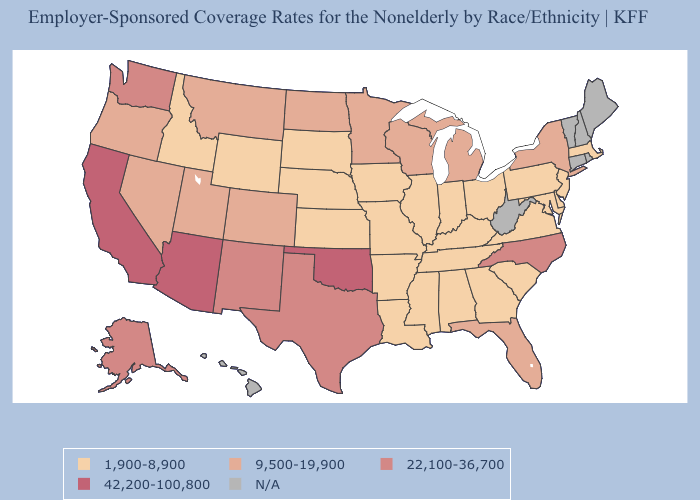Is the legend a continuous bar?
Answer briefly. No. Does North Carolina have the lowest value in the USA?
Keep it brief. No. What is the value of Washington?
Concise answer only. 22,100-36,700. Which states have the lowest value in the USA?
Short answer required. Alabama, Arkansas, Delaware, Georgia, Idaho, Illinois, Indiana, Iowa, Kansas, Kentucky, Louisiana, Maryland, Massachusetts, Mississippi, Missouri, Nebraska, New Jersey, Ohio, Pennsylvania, South Carolina, South Dakota, Tennessee, Virginia, Wyoming. What is the highest value in the USA?
Short answer required. 42,200-100,800. Does the map have missing data?
Be succinct. Yes. What is the value of Illinois?
Quick response, please. 1,900-8,900. What is the value of Kansas?
Answer briefly. 1,900-8,900. What is the value of Oklahoma?
Write a very short answer. 42,200-100,800. Name the states that have a value in the range 22,100-36,700?
Give a very brief answer. Alaska, New Mexico, North Carolina, Texas, Washington. Does Wyoming have the highest value in the West?
Concise answer only. No. Name the states that have a value in the range 9,500-19,900?
Answer briefly. Colorado, Florida, Michigan, Minnesota, Montana, Nevada, New York, North Dakota, Oregon, Utah, Wisconsin. What is the highest value in the USA?
Concise answer only. 42,200-100,800. What is the value of Louisiana?
Keep it brief. 1,900-8,900. 